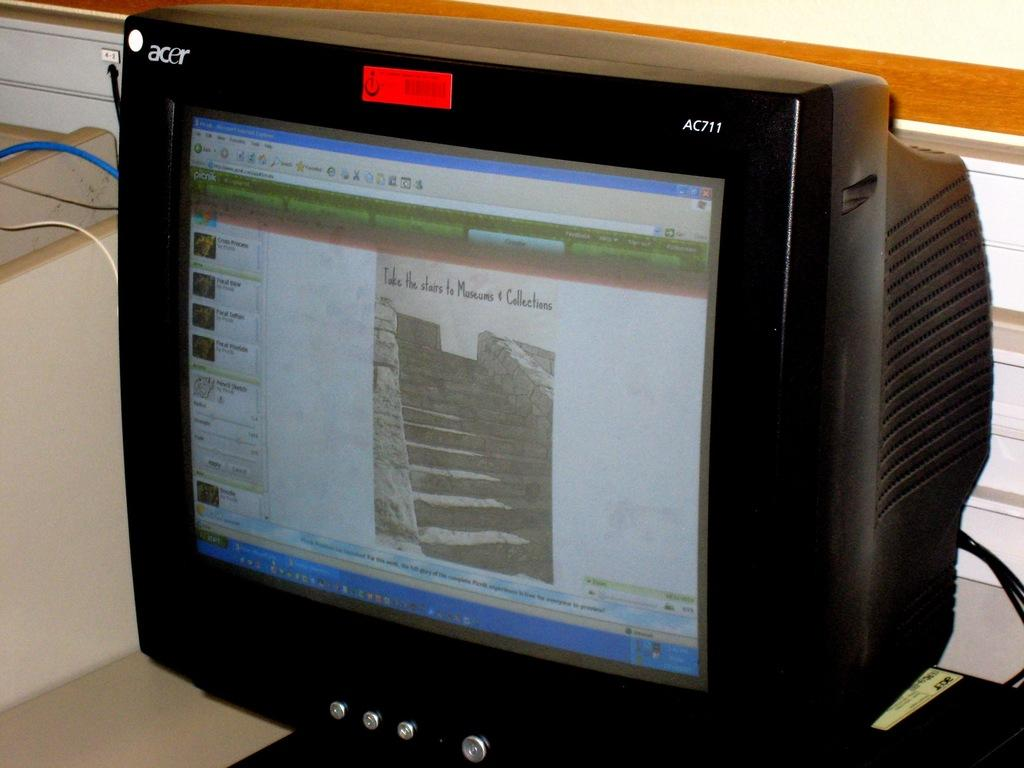<image>
Render a clear and concise summary of the photo. acer ac711 tube tv that has image of stairs and message take the stairs to museums & collections 